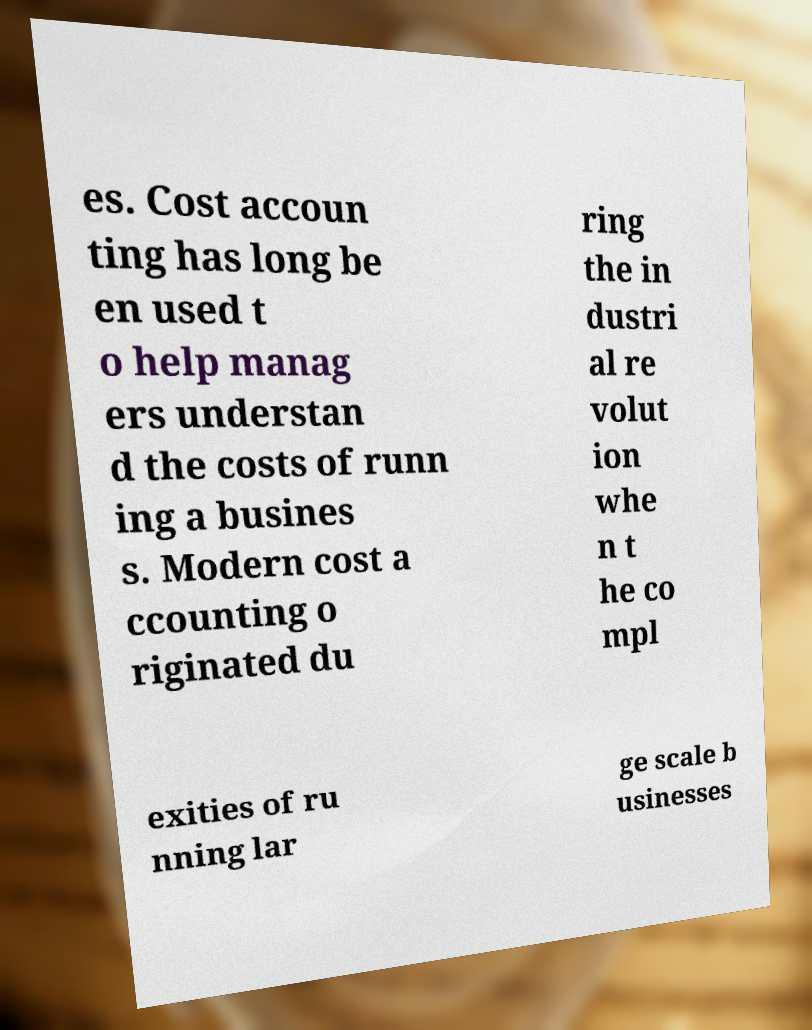Could you assist in decoding the text presented in this image and type it out clearly? es. Cost accoun ting has long be en used t o help manag ers understan d the costs of runn ing a busines s. Modern cost a ccounting o riginated du ring the in dustri al re volut ion whe n t he co mpl exities of ru nning lar ge scale b usinesses 